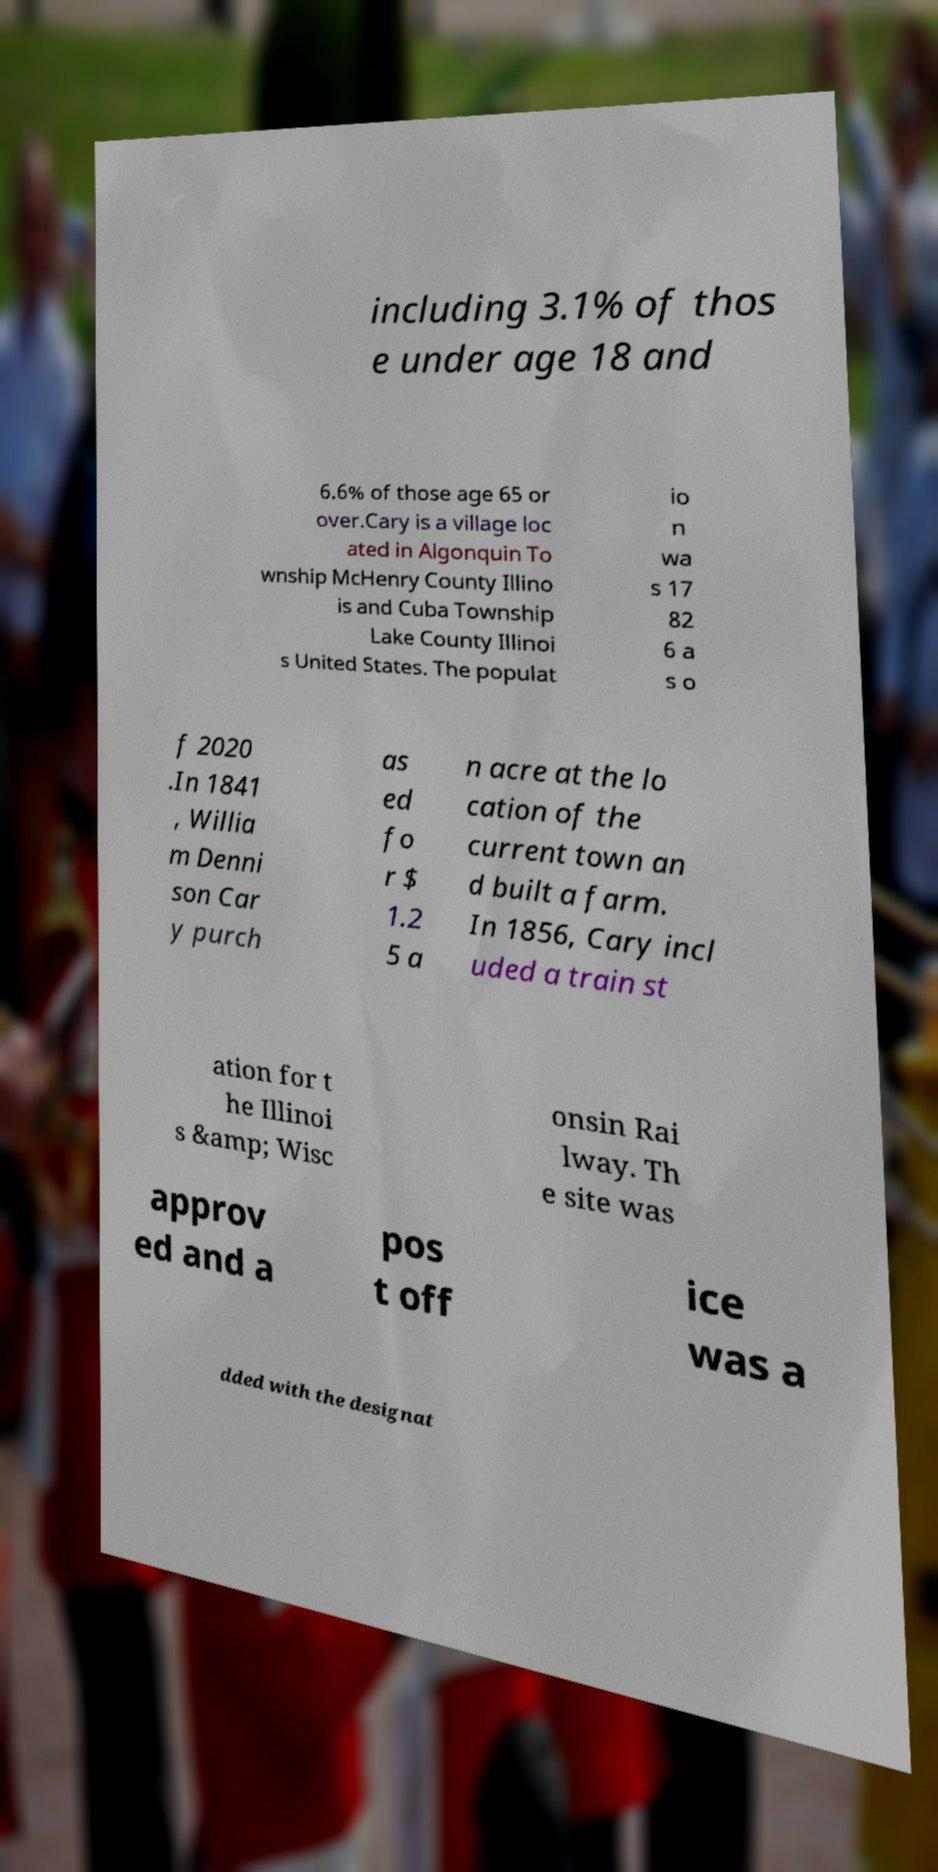Could you assist in decoding the text presented in this image and type it out clearly? including 3.1% of thos e under age 18 and 6.6% of those age 65 or over.Cary is a village loc ated in Algonquin To wnship McHenry County Illino is and Cuba Township Lake County Illinoi s United States. The populat io n wa s 17 82 6 a s o f 2020 .In 1841 , Willia m Denni son Car y purch as ed fo r $ 1.2 5 a n acre at the lo cation of the current town an d built a farm. In 1856, Cary incl uded a train st ation for t he Illinoi s &amp; Wisc onsin Rai lway. Th e site was approv ed and a pos t off ice was a dded with the designat 